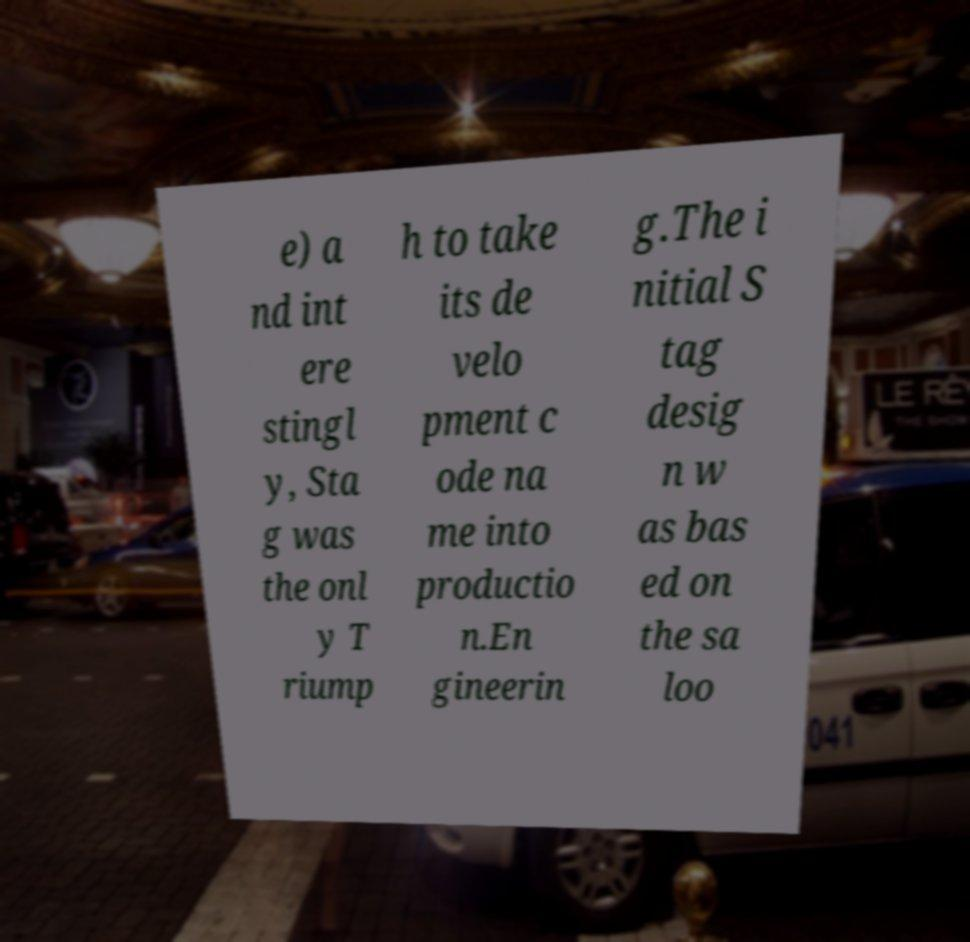Could you assist in decoding the text presented in this image and type it out clearly? e) a nd int ere stingl y, Sta g was the onl y T riump h to take its de velo pment c ode na me into productio n.En gineerin g.The i nitial S tag desig n w as bas ed on the sa loo 